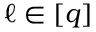Convert formula to latex. <formula><loc_0><loc_0><loc_500><loc_500>\ell \in [ q ]</formula> 